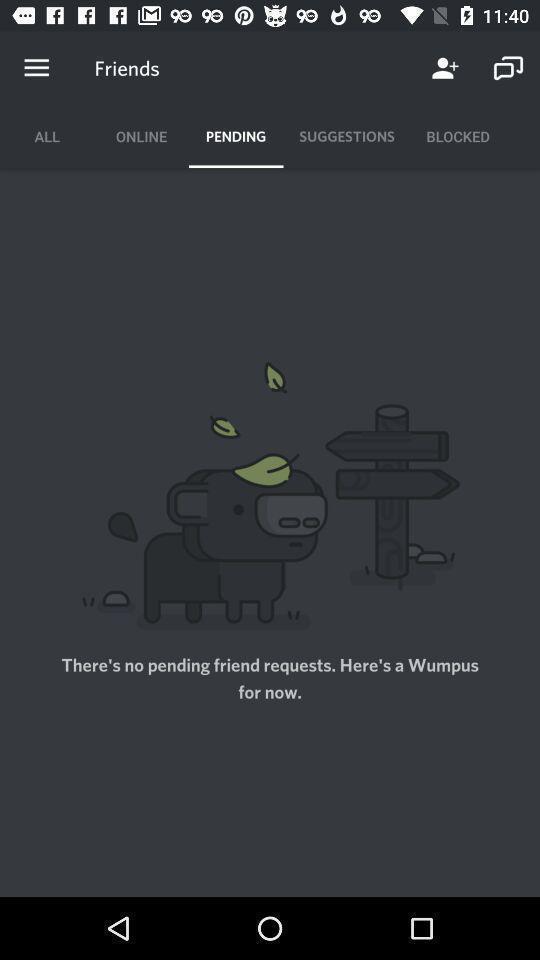What can you discern from this picture? Screen displaying the page of a social app. 